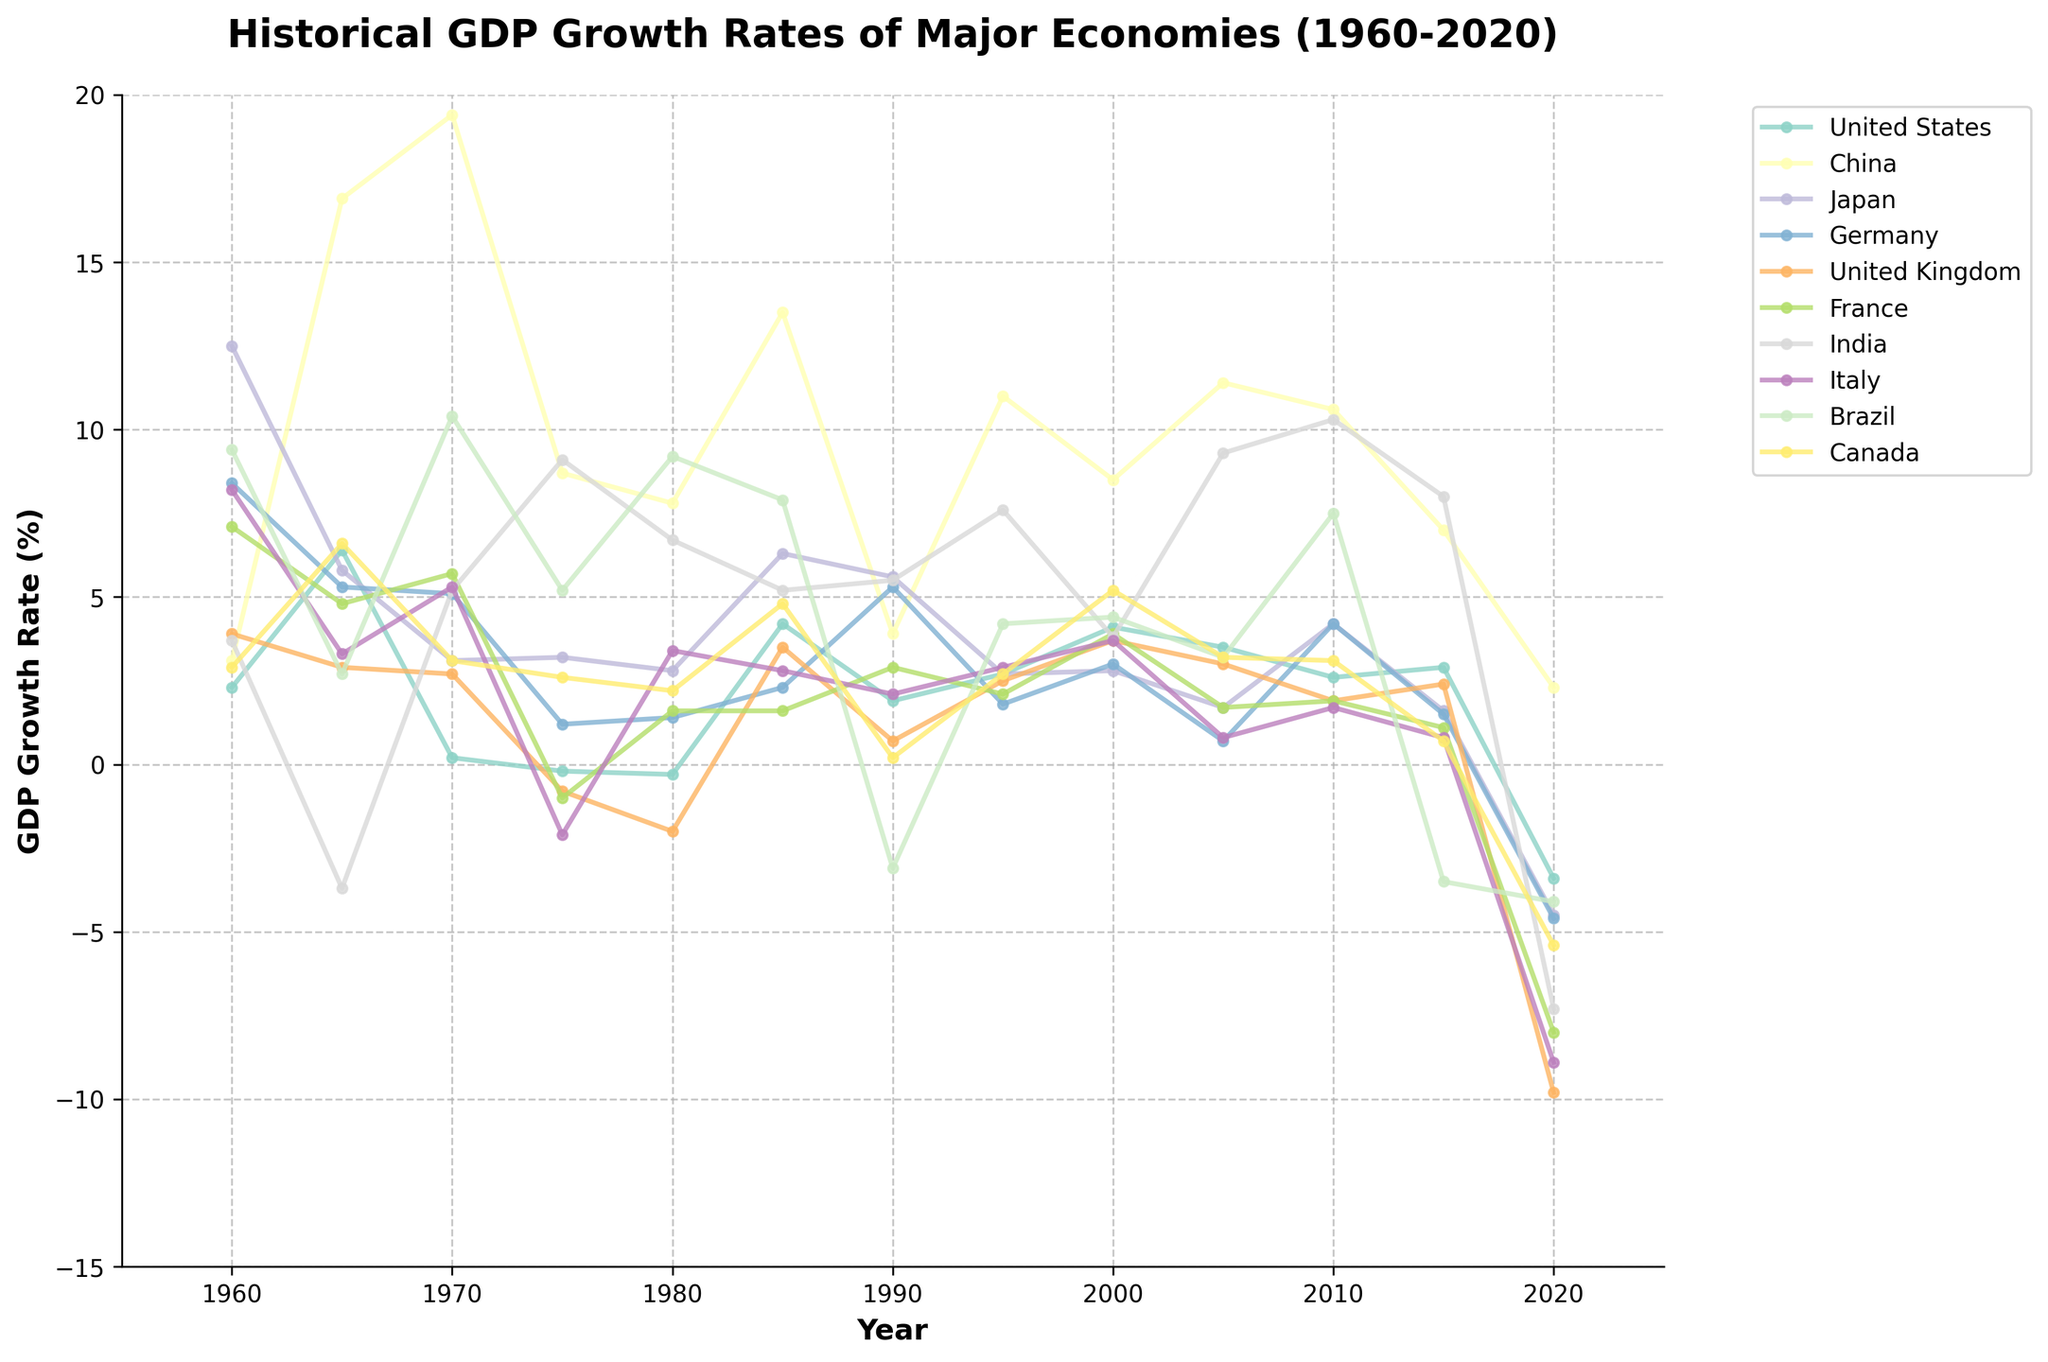Which country experienced the highest GDP growth rate in 1965? Look for the country with the highest point on the graph for the year 1965. The highest point corresponds to China's growth rate of 16.9%.
Answer: China Between 1960 and 2020, which country had the highest average GDP growth rate? Calculate the average GDP growth rate for each country over the entire period. By visually estimating, China shows consistently high growth rates, implying it has the highest average.
Answer: China During which year did the United Kingdom experience the lowest GDP growth rate? Identify the lowest point on the UK's line in the graph. In 2020, the UK had the lowest GDP growth rate at -9.8%.
Answer: 2020 Compare the GDP growth rates of India and Brazil in 2010. Which country had a higher growth rate? Look at the points for both India and Brazil in 2010. India's growth rate (10.3%) is higher than Brazil's (7.5%).
Answer: India What was the total GDP growth rate of Germany from 1980 to 1990? Sum the GDP growth rates of Germany for 1980 (1.4%), 1985 (2.3%), and 1990 (5.3%). 1.4 + 2.3 + 5.3 = 9.0
Answer: 9.0% Calculate the difference in GDP growth rates between Japan and Italy in 1975. Subtract Italy’s growth rate of -2.1% from Japan’s growth rate of 3.2%. 3.2 - (-2.1) = 5.3
Answer: 5.3% Which country had a more consistent GDP growth rate from 1960 to 2020, the United States or Germany? Consistency can be interpreted as less fluctuation in growth rates. Visually, the US line fluctuates less than Germany's, indicating the US had a more consistent growth rate.
Answer: United States In which decade did Canada experience the highest average GDP growth rate? Divide the graph into decades and visually estimate the average growth rate for Canada in each. The highest average appears in the 1960s.
Answer: 1960s 